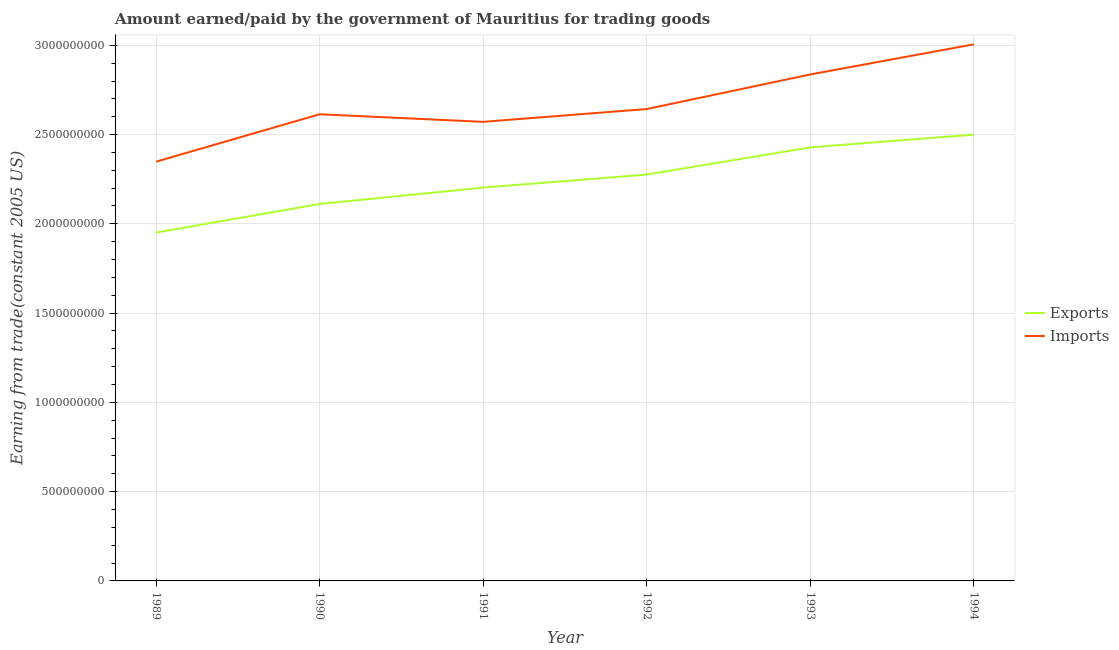How many different coloured lines are there?
Make the answer very short. 2. What is the amount paid for imports in 1990?
Offer a very short reply. 2.61e+09. Across all years, what is the maximum amount paid for imports?
Keep it short and to the point. 3.01e+09. Across all years, what is the minimum amount earned from exports?
Your response must be concise. 1.95e+09. In which year was the amount earned from exports minimum?
Your answer should be compact. 1989. What is the total amount earned from exports in the graph?
Your answer should be compact. 1.35e+1. What is the difference between the amount paid for imports in 1990 and that in 1994?
Provide a short and direct response. -3.92e+08. What is the difference between the amount paid for imports in 1989 and the amount earned from exports in 1990?
Provide a short and direct response. 2.37e+08. What is the average amount paid for imports per year?
Provide a succinct answer. 2.67e+09. In the year 1993, what is the difference between the amount earned from exports and amount paid for imports?
Your response must be concise. -4.08e+08. What is the ratio of the amount paid for imports in 1991 to that in 1992?
Provide a succinct answer. 0.97. What is the difference between the highest and the second highest amount earned from exports?
Offer a very short reply. 7.09e+07. What is the difference between the highest and the lowest amount earned from exports?
Your response must be concise. 5.48e+08. In how many years, is the amount paid for imports greater than the average amount paid for imports taken over all years?
Keep it short and to the point. 2. Is the amount paid for imports strictly less than the amount earned from exports over the years?
Make the answer very short. No. How many lines are there?
Your answer should be very brief. 2. How many years are there in the graph?
Your answer should be very brief. 6. Are the values on the major ticks of Y-axis written in scientific E-notation?
Your answer should be very brief. No. Does the graph contain any zero values?
Provide a short and direct response. No. Where does the legend appear in the graph?
Provide a short and direct response. Center right. How many legend labels are there?
Offer a very short reply. 2. How are the legend labels stacked?
Offer a terse response. Vertical. What is the title of the graph?
Provide a short and direct response. Amount earned/paid by the government of Mauritius for trading goods. Does "Urban" appear as one of the legend labels in the graph?
Offer a very short reply. No. What is the label or title of the X-axis?
Your answer should be compact. Year. What is the label or title of the Y-axis?
Your answer should be compact. Earning from trade(constant 2005 US). What is the Earning from trade(constant 2005 US) in Exports in 1989?
Provide a short and direct response. 1.95e+09. What is the Earning from trade(constant 2005 US) in Imports in 1989?
Your answer should be compact. 2.35e+09. What is the Earning from trade(constant 2005 US) in Exports in 1990?
Your answer should be very brief. 2.11e+09. What is the Earning from trade(constant 2005 US) of Imports in 1990?
Provide a succinct answer. 2.61e+09. What is the Earning from trade(constant 2005 US) in Exports in 1991?
Your response must be concise. 2.20e+09. What is the Earning from trade(constant 2005 US) in Imports in 1991?
Your response must be concise. 2.57e+09. What is the Earning from trade(constant 2005 US) in Exports in 1992?
Give a very brief answer. 2.28e+09. What is the Earning from trade(constant 2005 US) in Imports in 1992?
Provide a short and direct response. 2.64e+09. What is the Earning from trade(constant 2005 US) in Exports in 1993?
Offer a very short reply. 2.43e+09. What is the Earning from trade(constant 2005 US) of Imports in 1993?
Offer a terse response. 2.84e+09. What is the Earning from trade(constant 2005 US) in Exports in 1994?
Make the answer very short. 2.50e+09. What is the Earning from trade(constant 2005 US) in Imports in 1994?
Your answer should be very brief. 3.01e+09. Across all years, what is the maximum Earning from trade(constant 2005 US) of Exports?
Provide a succinct answer. 2.50e+09. Across all years, what is the maximum Earning from trade(constant 2005 US) in Imports?
Provide a short and direct response. 3.01e+09. Across all years, what is the minimum Earning from trade(constant 2005 US) in Exports?
Your response must be concise. 1.95e+09. Across all years, what is the minimum Earning from trade(constant 2005 US) in Imports?
Make the answer very short. 2.35e+09. What is the total Earning from trade(constant 2005 US) of Exports in the graph?
Give a very brief answer. 1.35e+1. What is the total Earning from trade(constant 2005 US) of Imports in the graph?
Offer a very short reply. 1.60e+1. What is the difference between the Earning from trade(constant 2005 US) of Exports in 1989 and that in 1990?
Make the answer very short. -1.60e+08. What is the difference between the Earning from trade(constant 2005 US) in Imports in 1989 and that in 1990?
Your answer should be very brief. -2.65e+08. What is the difference between the Earning from trade(constant 2005 US) in Exports in 1989 and that in 1991?
Make the answer very short. -2.52e+08. What is the difference between the Earning from trade(constant 2005 US) of Imports in 1989 and that in 1991?
Your response must be concise. -2.23e+08. What is the difference between the Earning from trade(constant 2005 US) of Exports in 1989 and that in 1992?
Ensure brevity in your answer.  -3.25e+08. What is the difference between the Earning from trade(constant 2005 US) in Imports in 1989 and that in 1992?
Provide a short and direct response. -2.95e+08. What is the difference between the Earning from trade(constant 2005 US) in Exports in 1989 and that in 1993?
Your response must be concise. -4.77e+08. What is the difference between the Earning from trade(constant 2005 US) in Imports in 1989 and that in 1993?
Offer a terse response. -4.88e+08. What is the difference between the Earning from trade(constant 2005 US) of Exports in 1989 and that in 1994?
Provide a succinct answer. -5.48e+08. What is the difference between the Earning from trade(constant 2005 US) of Imports in 1989 and that in 1994?
Provide a short and direct response. -6.57e+08. What is the difference between the Earning from trade(constant 2005 US) in Exports in 1990 and that in 1991?
Your answer should be very brief. -9.20e+07. What is the difference between the Earning from trade(constant 2005 US) of Imports in 1990 and that in 1991?
Provide a succinct answer. 4.24e+07. What is the difference between the Earning from trade(constant 2005 US) in Exports in 1990 and that in 1992?
Your response must be concise. -1.65e+08. What is the difference between the Earning from trade(constant 2005 US) in Imports in 1990 and that in 1992?
Ensure brevity in your answer.  -2.93e+07. What is the difference between the Earning from trade(constant 2005 US) in Exports in 1990 and that in 1993?
Provide a succinct answer. -3.17e+08. What is the difference between the Earning from trade(constant 2005 US) of Imports in 1990 and that in 1993?
Your answer should be compact. -2.23e+08. What is the difference between the Earning from trade(constant 2005 US) of Exports in 1990 and that in 1994?
Offer a very short reply. -3.88e+08. What is the difference between the Earning from trade(constant 2005 US) in Imports in 1990 and that in 1994?
Offer a very short reply. -3.92e+08. What is the difference between the Earning from trade(constant 2005 US) in Exports in 1991 and that in 1992?
Ensure brevity in your answer.  -7.30e+07. What is the difference between the Earning from trade(constant 2005 US) in Imports in 1991 and that in 1992?
Your answer should be very brief. -7.17e+07. What is the difference between the Earning from trade(constant 2005 US) in Exports in 1991 and that in 1993?
Your answer should be compact. -2.25e+08. What is the difference between the Earning from trade(constant 2005 US) of Imports in 1991 and that in 1993?
Make the answer very short. -2.65e+08. What is the difference between the Earning from trade(constant 2005 US) in Exports in 1991 and that in 1994?
Offer a terse response. -2.96e+08. What is the difference between the Earning from trade(constant 2005 US) in Imports in 1991 and that in 1994?
Offer a very short reply. -4.34e+08. What is the difference between the Earning from trade(constant 2005 US) of Exports in 1992 and that in 1993?
Provide a short and direct response. -1.52e+08. What is the difference between the Earning from trade(constant 2005 US) of Imports in 1992 and that in 1993?
Offer a terse response. -1.94e+08. What is the difference between the Earning from trade(constant 2005 US) of Exports in 1992 and that in 1994?
Keep it short and to the point. -2.23e+08. What is the difference between the Earning from trade(constant 2005 US) of Imports in 1992 and that in 1994?
Make the answer very short. -3.63e+08. What is the difference between the Earning from trade(constant 2005 US) of Exports in 1993 and that in 1994?
Provide a succinct answer. -7.09e+07. What is the difference between the Earning from trade(constant 2005 US) in Imports in 1993 and that in 1994?
Make the answer very short. -1.69e+08. What is the difference between the Earning from trade(constant 2005 US) of Exports in 1989 and the Earning from trade(constant 2005 US) of Imports in 1990?
Your response must be concise. -6.63e+08. What is the difference between the Earning from trade(constant 2005 US) in Exports in 1989 and the Earning from trade(constant 2005 US) in Imports in 1991?
Your response must be concise. -6.20e+08. What is the difference between the Earning from trade(constant 2005 US) in Exports in 1989 and the Earning from trade(constant 2005 US) in Imports in 1992?
Your answer should be compact. -6.92e+08. What is the difference between the Earning from trade(constant 2005 US) of Exports in 1989 and the Earning from trade(constant 2005 US) of Imports in 1993?
Your answer should be very brief. -8.86e+08. What is the difference between the Earning from trade(constant 2005 US) in Exports in 1989 and the Earning from trade(constant 2005 US) in Imports in 1994?
Keep it short and to the point. -1.05e+09. What is the difference between the Earning from trade(constant 2005 US) of Exports in 1990 and the Earning from trade(constant 2005 US) of Imports in 1991?
Provide a succinct answer. -4.60e+08. What is the difference between the Earning from trade(constant 2005 US) in Exports in 1990 and the Earning from trade(constant 2005 US) in Imports in 1992?
Your answer should be very brief. -5.32e+08. What is the difference between the Earning from trade(constant 2005 US) of Exports in 1990 and the Earning from trade(constant 2005 US) of Imports in 1993?
Your answer should be very brief. -7.26e+08. What is the difference between the Earning from trade(constant 2005 US) in Exports in 1990 and the Earning from trade(constant 2005 US) in Imports in 1994?
Ensure brevity in your answer.  -8.95e+08. What is the difference between the Earning from trade(constant 2005 US) of Exports in 1991 and the Earning from trade(constant 2005 US) of Imports in 1992?
Give a very brief answer. -4.40e+08. What is the difference between the Earning from trade(constant 2005 US) in Exports in 1991 and the Earning from trade(constant 2005 US) in Imports in 1993?
Give a very brief answer. -6.34e+08. What is the difference between the Earning from trade(constant 2005 US) of Exports in 1991 and the Earning from trade(constant 2005 US) of Imports in 1994?
Provide a short and direct response. -8.03e+08. What is the difference between the Earning from trade(constant 2005 US) of Exports in 1992 and the Earning from trade(constant 2005 US) of Imports in 1993?
Keep it short and to the point. -5.61e+08. What is the difference between the Earning from trade(constant 2005 US) of Exports in 1992 and the Earning from trade(constant 2005 US) of Imports in 1994?
Offer a terse response. -7.30e+08. What is the difference between the Earning from trade(constant 2005 US) of Exports in 1993 and the Earning from trade(constant 2005 US) of Imports in 1994?
Provide a succinct answer. -5.77e+08. What is the average Earning from trade(constant 2005 US) in Exports per year?
Keep it short and to the point. 2.24e+09. What is the average Earning from trade(constant 2005 US) of Imports per year?
Your response must be concise. 2.67e+09. In the year 1989, what is the difference between the Earning from trade(constant 2005 US) of Exports and Earning from trade(constant 2005 US) of Imports?
Provide a short and direct response. -3.97e+08. In the year 1990, what is the difference between the Earning from trade(constant 2005 US) of Exports and Earning from trade(constant 2005 US) of Imports?
Your response must be concise. -5.03e+08. In the year 1991, what is the difference between the Earning from trade(constant 2005 US) in Exports and Earning from trade(constant 2005 US) in Imports?
Give a very brief answer. -3.68e+08. In the year 1992, what is the difference between the Earning from trade(constant 2005 US) of Exports and Earning from trade(constant 2005 US) of Imports?
Keep it short and to the point. -3.67e+08. In the year 1993, what is the difference between the Earning from trade(constant 2005 US) of Exports and Earning from trade(constant 2005 US) of Imports?
Your answer should be compact. -4.08e+08. In the year 1994, what is the difference between the Earning from trade(constant 2005 US) in Exports and Earning from trade(constant 2005 US) in Imports?
Offer a very short reply. -5.06e+08. What is the ratio of the Earning from trade(constant 2005 US) of Exports in 1989 to that in 1990?
Your response must be concise. 0.92. What is the ratio of the Earning from trade(constant 2005 US) of Imports in 1989 to that in 1990?
Offer a terse response. 0.9. What is the ratio of the Earning from trade(constant 2005 US) in Exports in 1989 to that in 1991?
Offer a terse response. 0.89. What is the ratio of the Earning from trade(constant 2005 US) in Imports in 1989 to that in 1991?
Your answer should be very brief. 0.91. What is the ratio of the Earning from trade(constant 2005 US) of Exports in 1989 to that in 1992?
Your answer should be compact. 0.86. What is the ratio of the Earning from trade(constant 2005 US) in Imports in 1989 to that in 1992?
Your answer should be very brief. 0.89. What is the ratio of the Earning from trade(constant 2005 US) of Exports in 1989 to that in 1993?
Your response must be concise. 0.8. What is the ratio of the Earning from trade(constant 2005 US) of Imports in 1989 to that in 1993?
Your response must be concise. 0.83. What is the ratio of the Earning from trade(constant 2005 US) of Exports in 1989 to that in 1994?
Provide a succinct answer. 0.78. What is the ratio of the Earning from trade(constant 2005 US) of Imports in 1989 to that in 1994?
Provide a short and direct response. 0.78. What is the ratio of the Earning from trade(constant 2005 US) of Imports in 1990 to that in 1991?
Your response must be concise. 1.02. What is the ratio of the Earning from trade(constant 2005 US) in Exports in 1990 to that in 1992?
Provide a succinct answer. 0.93. What is the ratio of the Earning from trade(constant 2005 US) of Imports in 1990 to that in 1992?
Offer a very short reply. 0.99. What is the ratio of the Earning from trade(constant 2005 US) in Exports in 1990 to that in 1993?
Make the answer very short. 0.87. What is the ratio of the Earning from trade(constant 2005 US) of Imports in 1990 to that in 1993?
Provide a succinct answer. 0.92. What is the ratio of the Earning from trade(constant 2005 US) of Exports in 1990 to that in 1994?
Your answer should be very brief. 0.84. What is the ratio of the Earning from trade(constant 2005 US) in Imports in 1990 to that in 1994?
Keep it short and to the point. 0.87. What is the ratio of the Earning from trade(constant 2005 US) of Exports in 1991 to that in 1992?
Your response must be concise. 0.97. What is the ratio of the Earning from trade(constant 2005 US) in Imports in 1991 to that in 1992?
Your answer should be compact. 0.97. What is the ratio of the Earning from trade(constant 2005 US) of Exports in 1991 to that in 1993?
Keep it short and to the point. 0.91. What is the ratio of the Earning from trade(constant 2005 US) of Imports in 1991 to that in 1993?
Ensure brevity in your answer.  0.91. What is the ratio of the Earning from trade(constant 2005 US) of Exports in 1991 to that in 1994?
Provide a short and direct response. 0.88. What is the ratio of the Earning from trade(constant 2005 US) of Imports in 1991 to that in 1994?
Make the answer very short. 0.86. What is the ratio of the Earning from trade(constant 2005 US) of Exports in 1992 to that in 1993?
Your answer should be compact. 0.94. What is the ratio of the Earning from trade(constant 2005 US) in Imports in 1992 to that in 1993?
Provide a succinct answer. 0.93. What is the ratio of the Earning from trade(constant 2005 US) in Exports in 1992 to that in 1994?
Keep it short and to the point. 0.91. What is the ratio of the Earning from trade(constant 2005 US) in Imports in 1992 to that in 1994?
Your answer should be compact. 0.88. What is the ratio of the Earning from trade(constant 2005 US) in Exports in 1993 to that in 1994?
Your answer should be compact. 0.97. What is the ratio of the Earning from trade(constant 2005 US) in Imports in 1993 to that in 1994?
Your response must be concise. 0.94. What is the difference between the highest and the second highest Earning from trade(constant 2005 US) of Exports?
Offer a terse response. 7.09e+07. What is the difference between the highest and the second highest Earning from trade(constant 2005 US) in Imports?
Your response must be concise. 1.69e+08. What is the difference between the highest and the lowest Earning from trade(constant 2005 US) of Exports?
Ensure brevity in your answer.  5.48e+08. What is the difference between the highest and the lowest Earning from trade(constant 2005 US) in Imports?
Keep it short and to the point. 6.57e+08. 